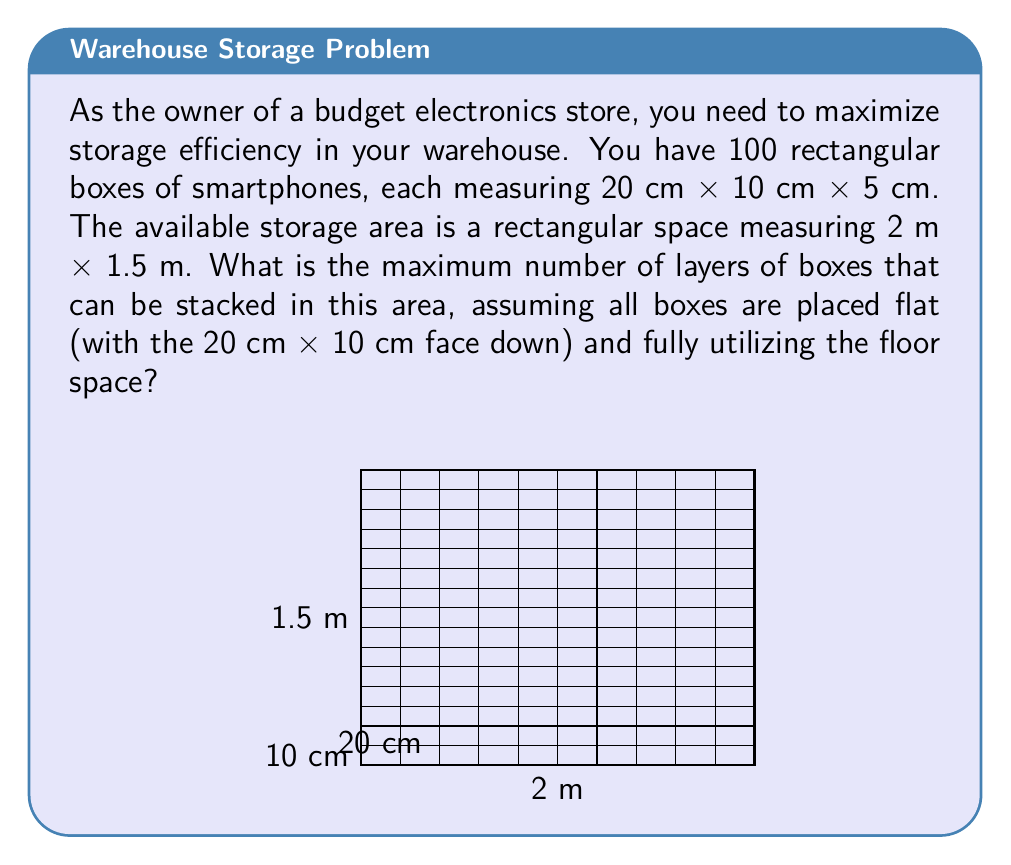What is the answer to this math problem? Let's approach this problem step-by-step:

1) First, we need to convert all measurements to the same unit. Let's use centimeters:
   Storage area: 200 cm × 150 cm
   Box dimensions: 20 cm × 10 cm × 5 cm

2) Calculate how many boxes can fit along the length of the storage area:
   $\frac{200 \text{ cm}}{20 \text{ cm}} = 10$ boxes

3) Calculate how many boxes can fit along the width of the storage area:
   $\frac{150 \text{ cm}}{10 \text{ cm}} = 15$ boxes

4) Calculate the total number of boxes that can fit in one layer:
   $10 \times 15 = 150$ boxes

5) Calculate how many layers we can create with 100 boxes:
   $\frac{100 \text{ boxes}}{150 \text{ boxes per layer}} \approx 0.67$ layers

6) However, we can't have a partial layer. We need to find out how many complete layers we can stack given the height of our storage area.

7) To do this, we need to know the height of our storage area, which isn't given. So, we'll calculate the maximum number of layers possible based on the number of boxes we have:

   $\left\lfloor\frac{100 \text{ boxes}}{150 \text{ boxes per layer}}\right\rfloor = 0$ layers

   Where $\lfloor \cdot \rfloor$ denotes the floor function (rounding down to the nearest integer).

Therefore, we can only create 0 complete layers with 100 boxes, as we don't have enough boxes to fill even one layer completely.
Answer: 0 layers 